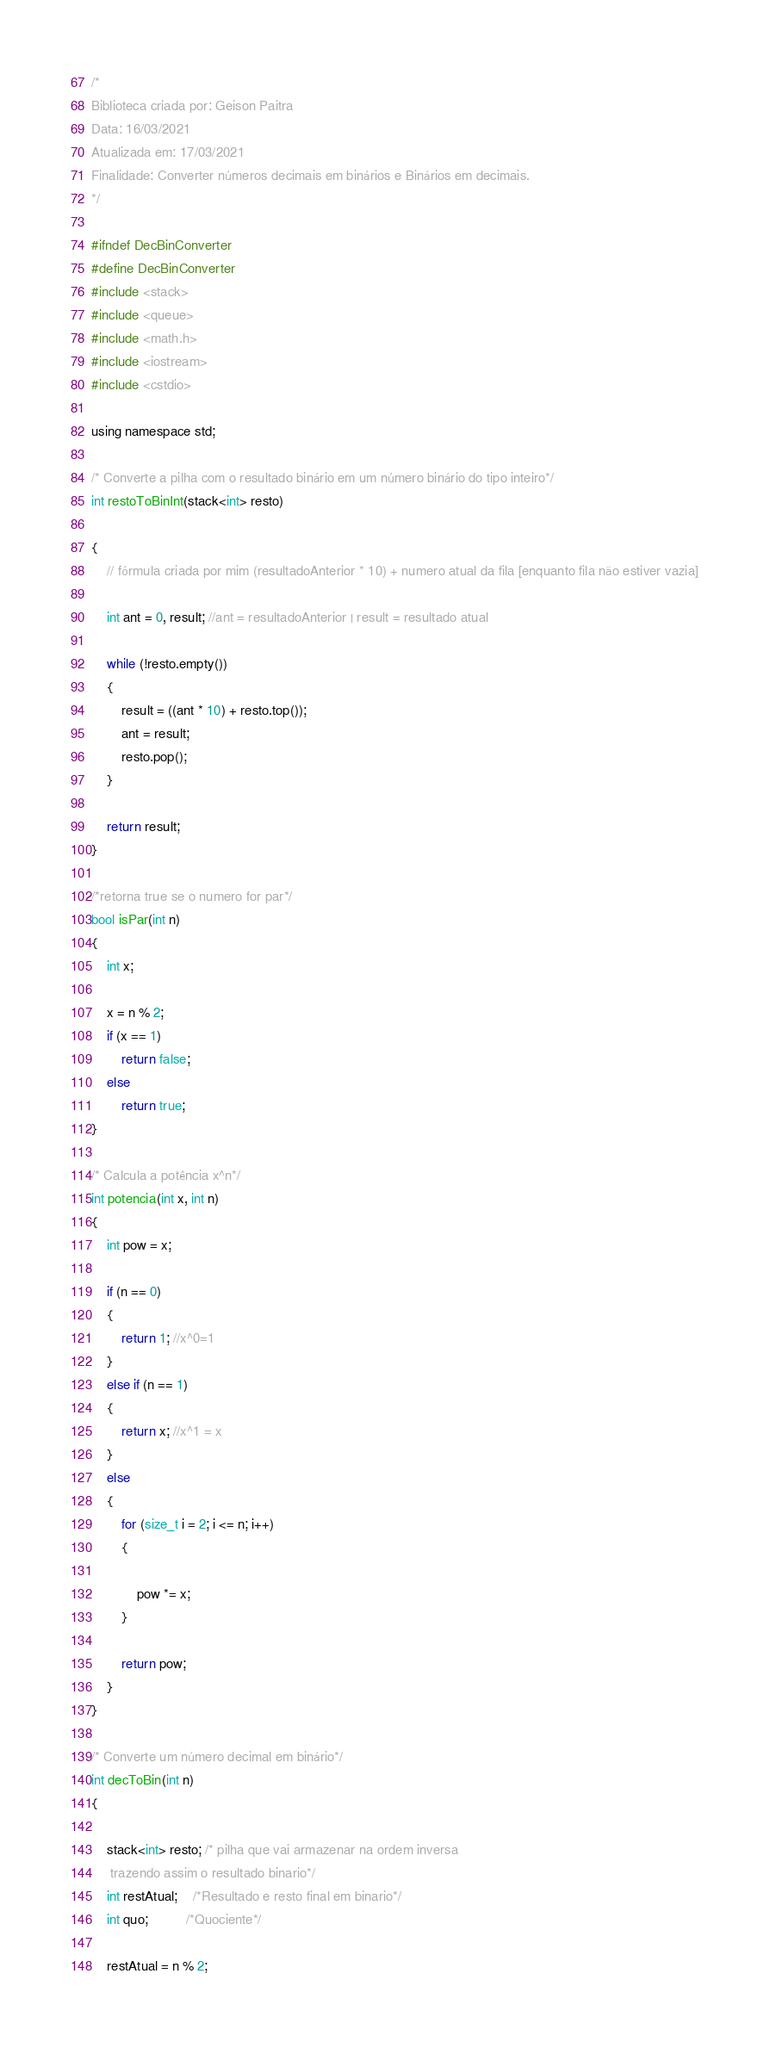Convert code to text. <code><loc_0><loc_0><loc_500><loc_500><_C_>/*
Biblioteca criada por: Geison Paitra
Data: 16/03/2021
Atualizada em: 17/03/2021
Finalidade: Converter números decimais em binários e Binários em decimais.
*/

#ifndef DecBinConverter
#define DecBinConverter
#include <stack>
#include <queue>
#include <math.h>
#include <iostream>
#include <cstdio>

using namespace std;

/* Converte a pilha com o resultado binário em um número binário do tipo inteiro*/
int restoToBinInt(stack<int> resto)

{
    // fórmula criada por mim (resultadoAnterior * 10) + numero atual da fila [enquanto fila não estiver vazia]

    int ant = 0, result; //ant = resultadoAnterior | result = resultado atual

    while (!resto.empty())
    {
        result = ((ant * 10) + resto.top());
        ant = result;
        resto.pop();
    }

    return result;
}

/*retorna true se o numero for par*/
bool isPar(int n)
{
    int x;

    x = n % 2;
    if (x == 1)
        return false;
    else
        return true;
}

/* Calcula a potência x^n*/
int potencia(int x, int n)
{
    int pow = x;

    if (n == 0)
    {
        return 1; //x^0=1
    }
    else if (n == 1)
    {
        return x; //x^1 = x
    }
    else
    {
        for (size_t i = 2; i <= n; i++)
        {

            pow *= x;
        }

        return pow;
    }
}

/* Converte um número decimal em binário*/
int decToBin(int n)
{

    stack<int> resto; /* pilha que vai armazenar na ordem inversa
     trazendo assim o resultado binario*/
    int restAtual;    /*Resultado e resto final em binario*/
    int quo;          /*Quociente*/

    restAtual = n % 2;</code> 